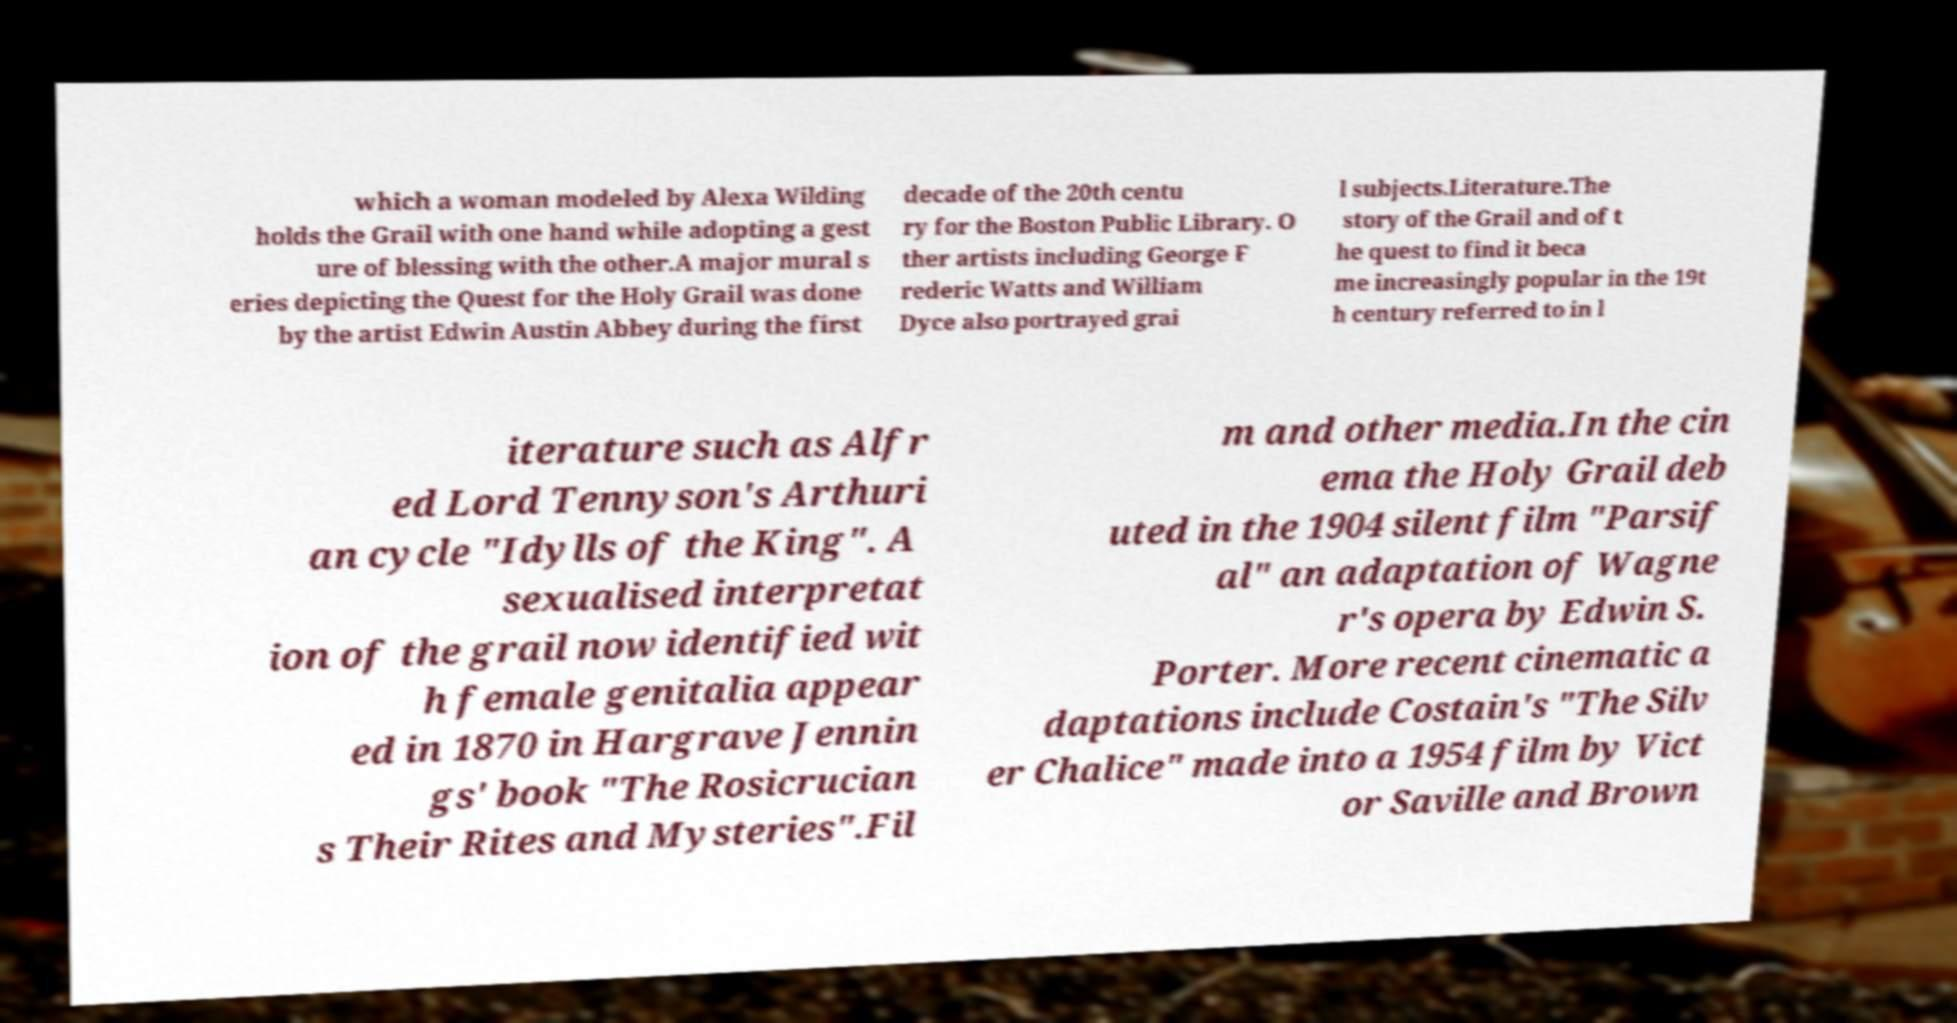Can you accurately transcribe the text from the provided image for me? which a woman modeled by Alexa Wilding holds the Grail with one hand while adopting a gest ure of blessing with the other.A major mural s eries depicting the Quest for the Holy Grail was done by the artist Edwin Austin Abbey during the first decade of the 20th centu ry for the Boston Public Library. O ther artists including George F rederic Watts and William Dyce also portrayed grai l subjects.Literature.The story of the Grail and of t he quest to find it beca me increasingly popular in the 19t h century referred to in l iterature such as Alfr ed Lord Tennyson's Arthuri an cycle "Idylls of the King". A sexualised interpretat ion of the grail now identified wit h female genitalia appear ed in 1870 in Hargrave Jennin gs' book "The Rosicrucian s Their Rites and Mysteries".Fil m and other media.In the cin ema the Holy Grail deb uted in the 1904 silent film "Parsif al" an adaptation of Wagne r's opera by Edwin S. Porter. More recent cinematic a daptations include Costain's "The Silv er Chalice" made into a 1954 film by Vict or Saville and Brown 